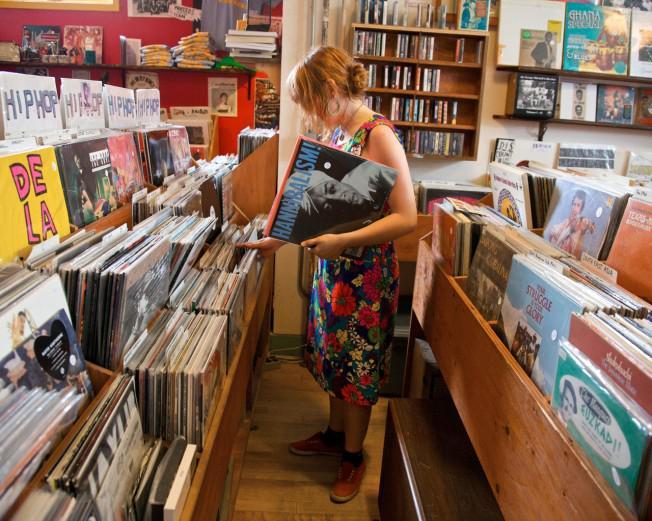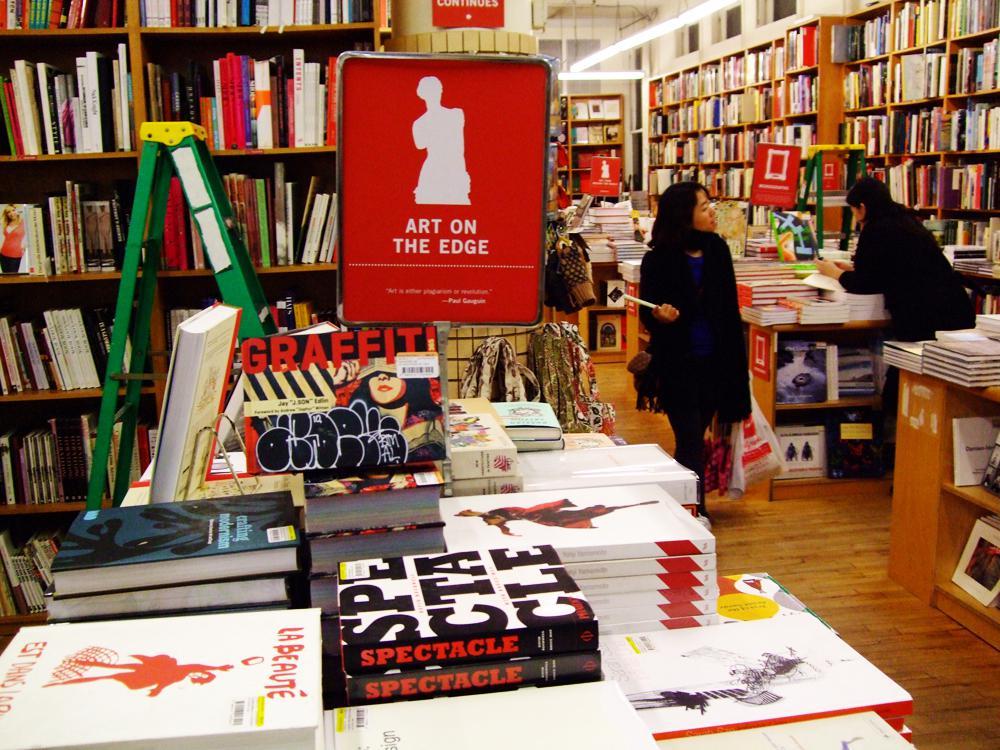The first image is the image on the left, the second image is the image on the right. Considering the images on both sides, is "All of the people in the shop are men." valid? Answer yes or no. No. The first image is the image on the left, the second image is the image on the right. Considering the images on both sides, is "All people are standing." valid? Answer yes or no. Yes. 